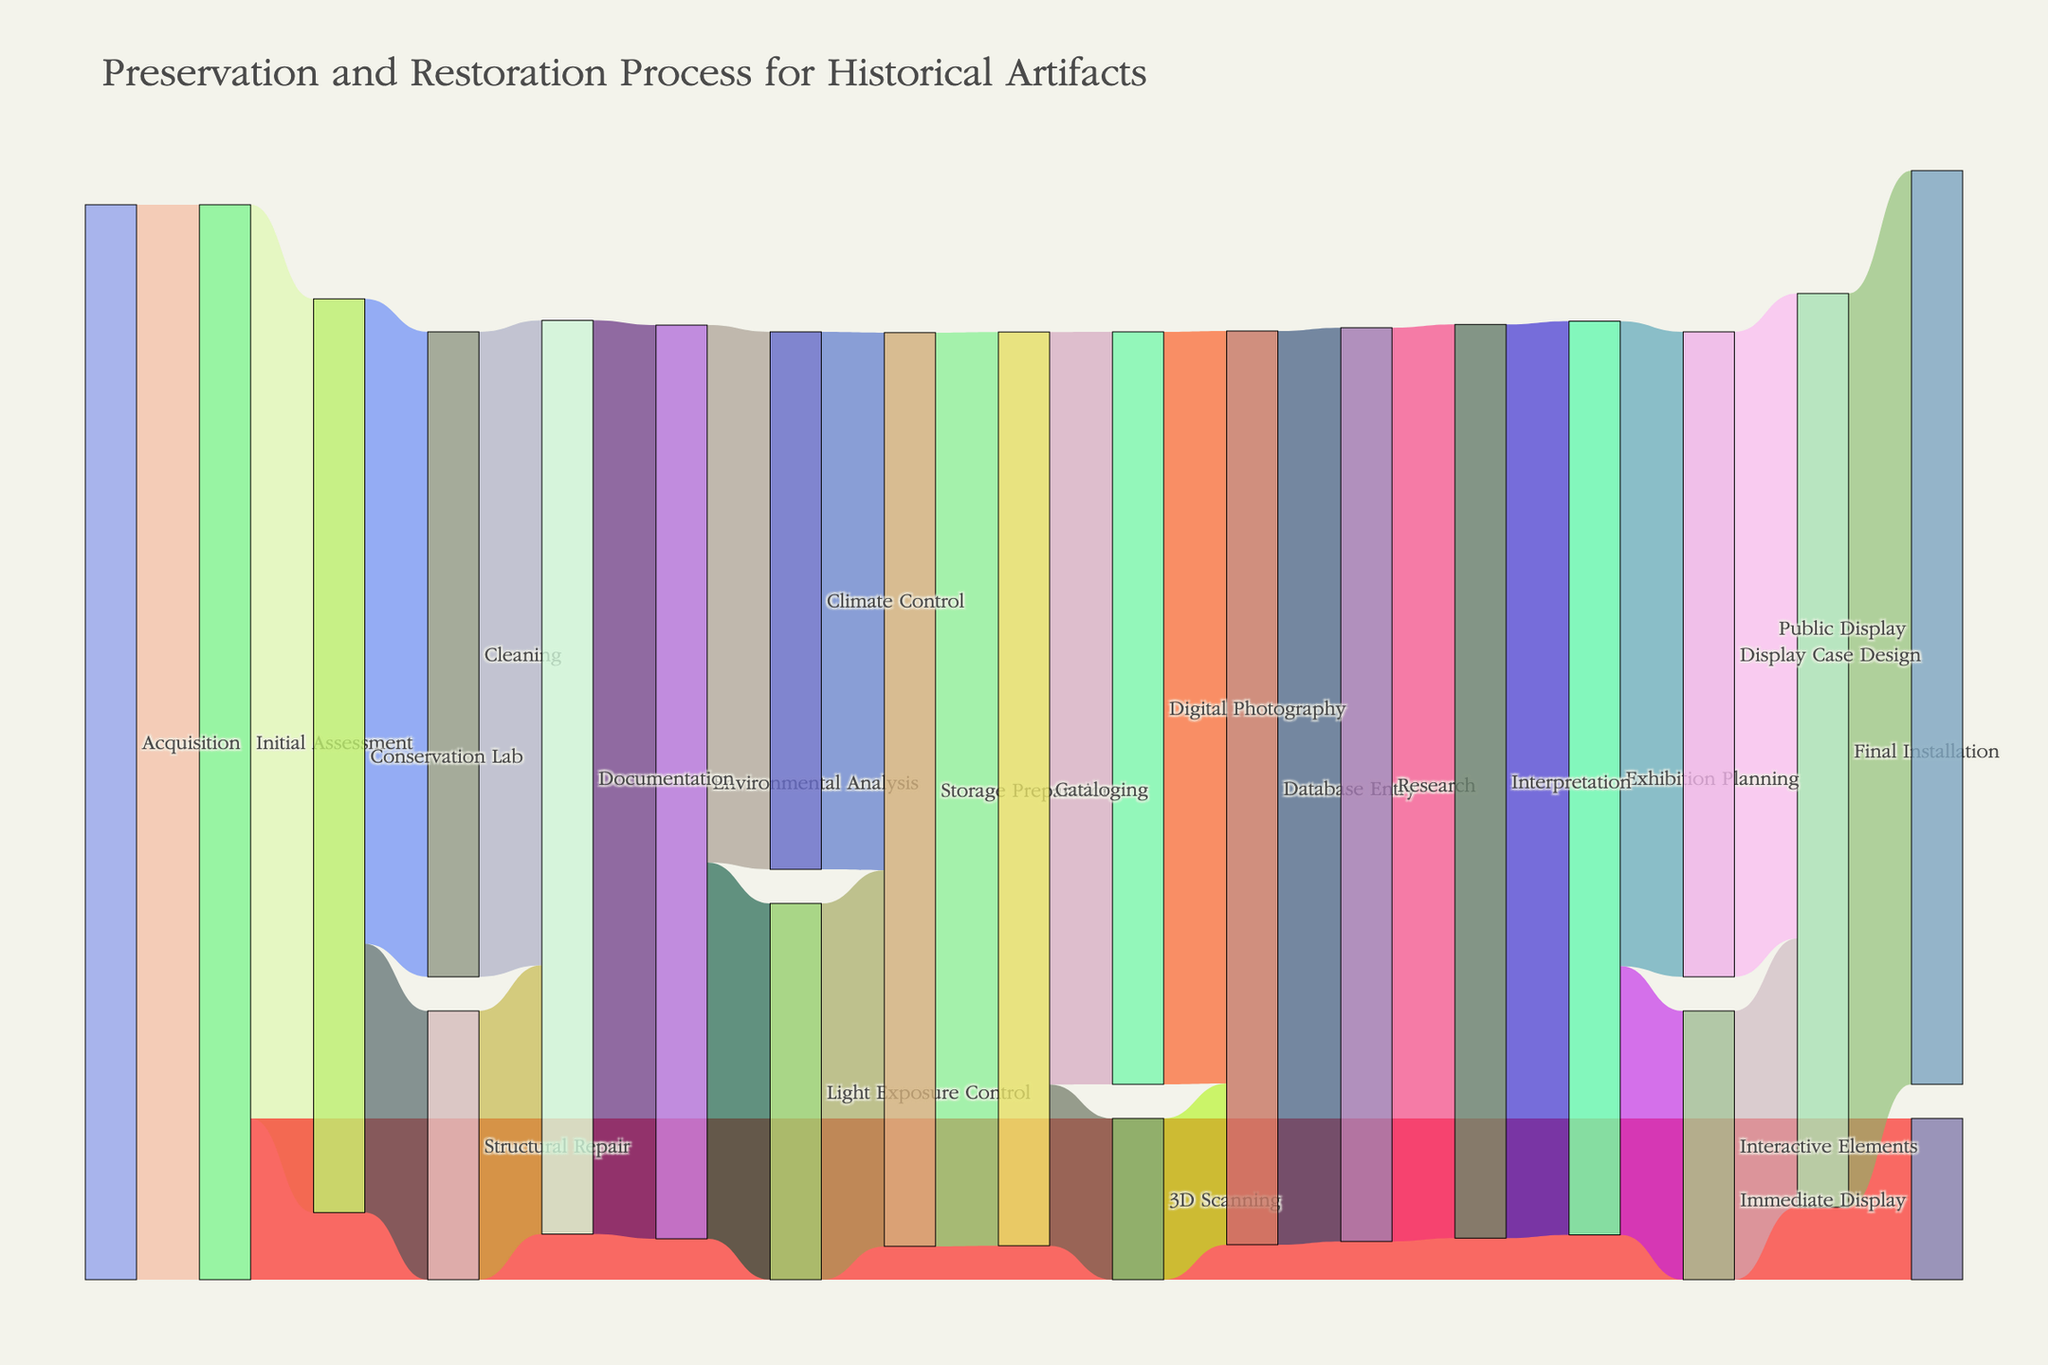How many artifacts go directly to Immediate Display after Initial Assessment? To find the answer, look for the flow from "Initial Assessment" to "Immediate Display". The value here is labeled 15.
Answer: 15 What is the total number of artifacts that end up in Documentation after leaving the Conservation Lab? First, find the number of artifacts flowing into Documentation from both Cleaning and Structural Repair, which are 60 and 25, respectively. Add these values together: 60 + 25 = 85.
Answer: 85 Which stage has the highest number of artifacts directly flowing into Public Display? Follow the flow towards "Public Display". The flow immediately before "Public Display" is "Final Installation", which has 85 artifacts transitioning into "Public Display".
Answer: Final Installation Compare the number of artifacts undergoing Environmental Analysis to those entering the Conservation Lab. Which is higher? Look at the values flowing into "Environmental Analysis" and "Conservation Lab". "Environmental Analysis" receives 85 artifacts, whereas "Conservation Lab" receives 85 artifacts from Initial Assessment. They are equal.
Answer: Equal Calculate the total number of artifacts that go through both Climate Control and Light Exposure Control combined. Find the number of artifacts flowing into "Climate Control" and "Light Exposure Control," which are 50 and 35 respectively. Add these values: 50 + 35 = 85.
Answer: 85 How many artifacts proceed to Digital Photography after Cataloging? Locate the flow from "Cataloging" to "Digital Photography". It shows 70 artifacts.
Answer: 70 What’s the difference between the number of artifacts that are 3D Scanned and those that undergo Digital Photography? Identify the numbers for "3D Scanning" and "Digital Photography", which are 15 and 70 respectively. Subtract the smaller number from the larger one: 70 - 15 = 55.
Answer: 55 Which process has the smallest value attributed to it? Scan through the values associated with every stage to determine the smallest. The smallest value is 15, attributed to "Immediate Display", "3D Scanning", and "Database Entry".
Answer: Immediate Display, 3D Scanning, Database Entry 